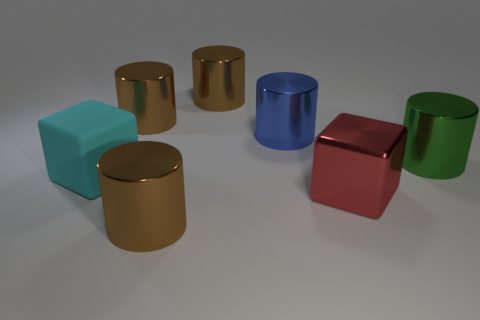How many large green cylinders are left of the cyan block?
Your response must be concise. 0. What number of brown cylinders are there?
Offer a very short reply. 3. Does the blue metal cylinder have the same size as the green metal object?
Your response must be concise. Yes. There is a large brown shiny cylinder in front of the big cyan rubber thing on the left side of the big blue object; are there any big green metallic objects in front of it?
Offer a very short reply. No. There is a cyan object that is the same shape as the red metallic object; what material is it?
Give a very brief answer. Rubber. The big cube to the right of the cyan rubber object is what color?
Ensure brevity in your answer.  Red. The green object has what size?
Make the answer very short. Large. Do the matte block and the brown thing that is in front of the green metal cylinder have the same size?
Ensure brevity in your answer.  Yes. What color is the large block left of the brown metal cylinder that is in front of the large metallic thing right of the large red metallic block?
Provide a succinct answer. Cyan. Is the big cylinder in front of the cyan object made of the same material as the big cyan cube?
Keep it short and to the point. No. 